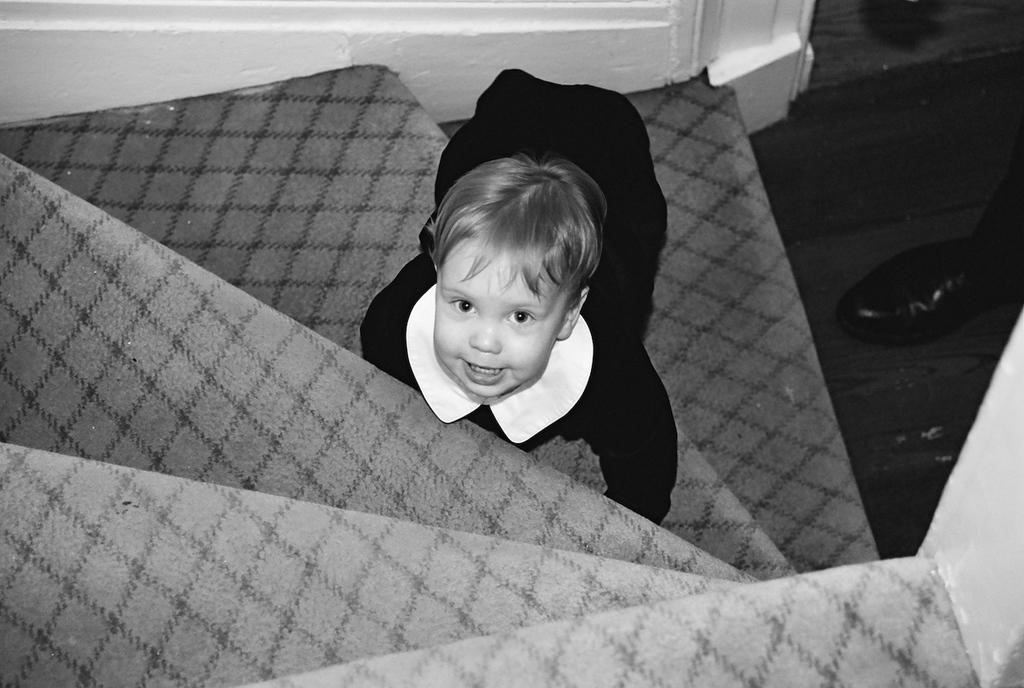Who is the main subject in the image? There is a child in the image. Where is the child located in the image? The child is on the stairs. What can be seen on the right side of the image? There are shoes on the right side of the image. What is the color scheme of the image? The image is black and white. How many eyes can be seen on the stone in the image? There is no stone present in the image, and therefore no eyes can be seen on it. 